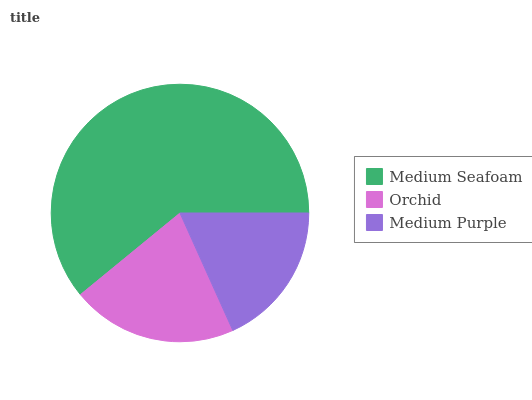Is Medium Purple the minimum?
Answer yes or no. Yes. Is Medium Seafoam the maximum?
Answer yes or no. Yes. Is Orchid the minimum?
Answer yes or no. No. Is Orchid the maximum?
Answer yes or no. No. Is Medium Seafoam greater than Orchid?
Answer yes or no. Yes. Is Orchid less than Medium Seafoam?
Answer yes or no. Yes. Is Orchid greater than Medium Seafoam?
Answer yes or no. No. Is Medium Seafoam less than Orchid?
Answer yes or no. No. Is Orchid the high median?
Answer yes or no. Yes. Is Orchid the low median?
Answer yes or no. Yes. Is Medium Seafoam the high median?
Answer yes or no. No. Is Medium Seafoam the low median?
Answer yes or no. No. 